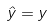Convert formula to latex. <formula><loc_0><loc_0><loc_500><loc_500>\hat { y } = y</formula> 